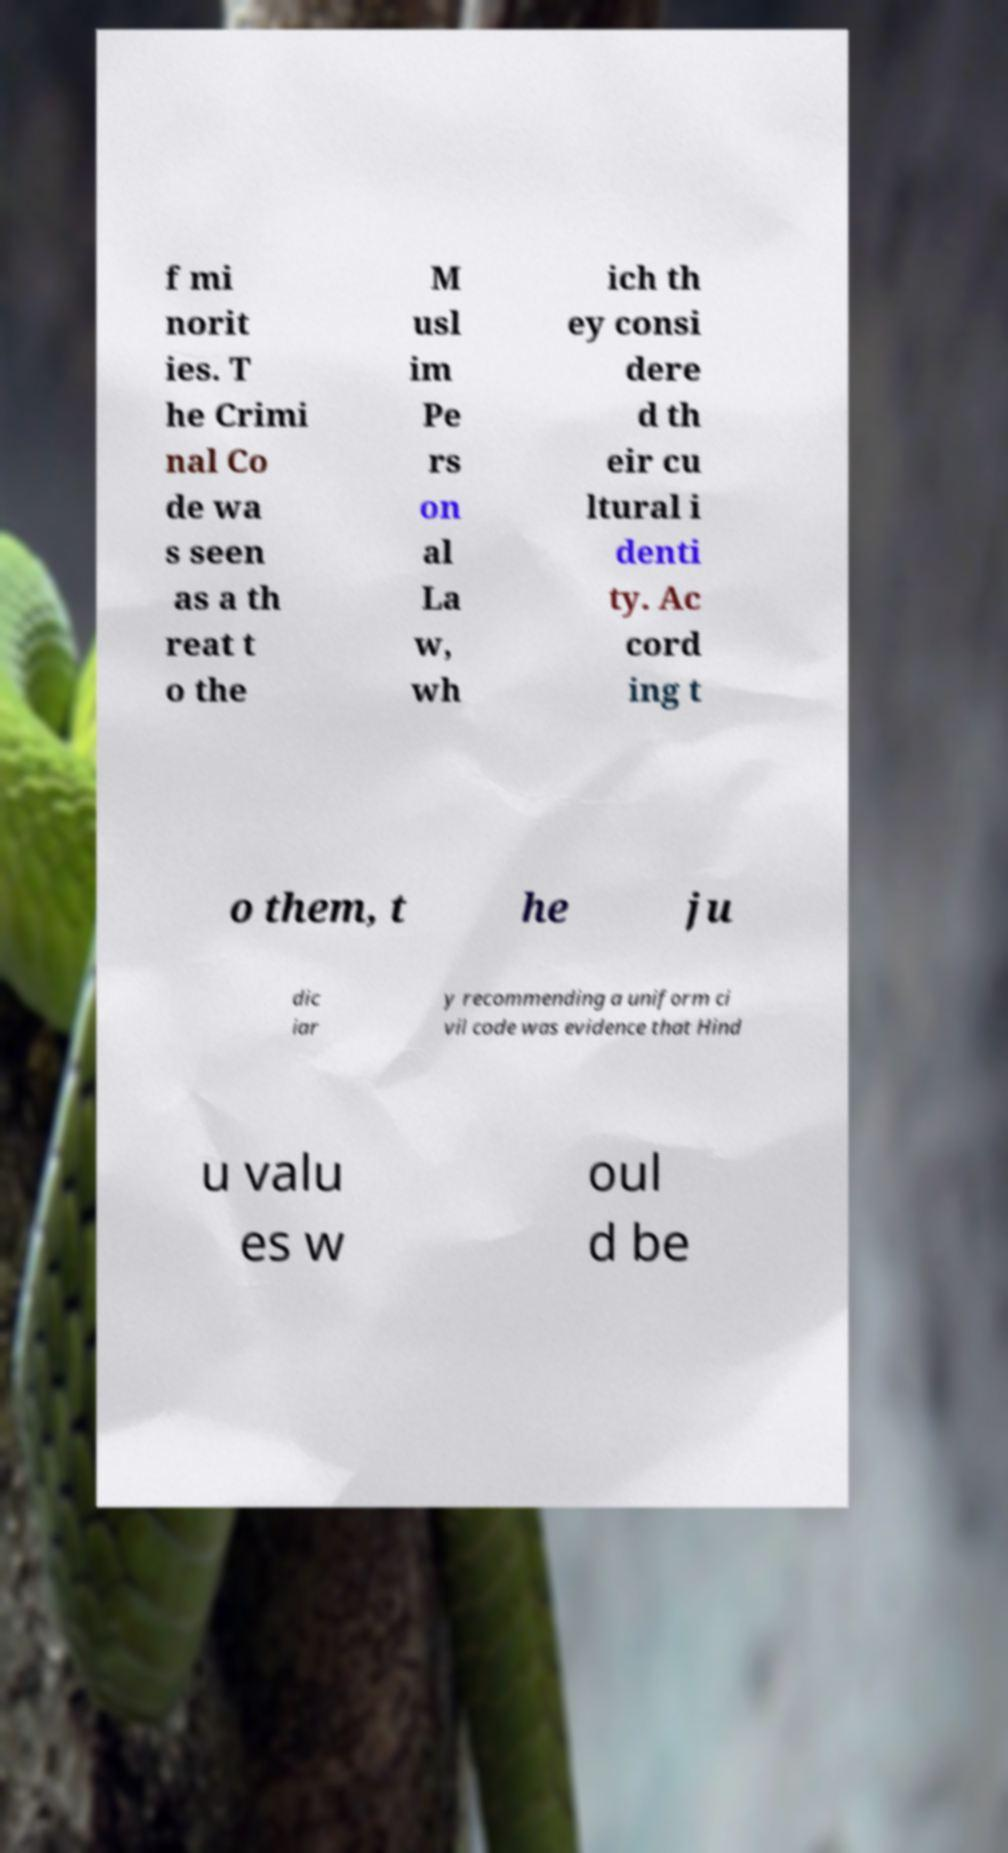What messages or text are displayed in this image? I need them in a readable, typed format. f mi norit ies. T he Crimi nal Co de wa s seen as a th reat t o the M usl im Pe rs on al La w, wh ich th ey consi dere d th eir cu ltural i denti ty. Ac cord ing t o them, t he ju dic iar y recommending a uniform ci vil code was evidence that Hind u valu es w oul d be 